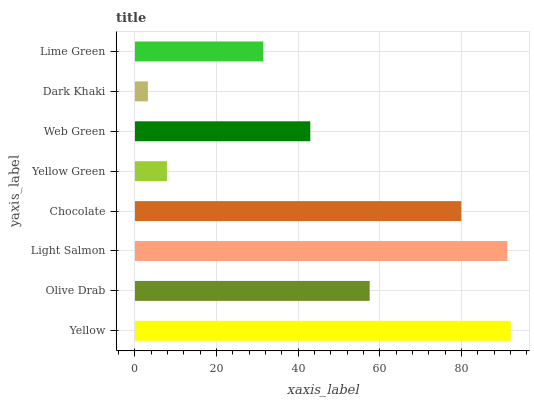Is Dark Khaki the minimum?
Answer yes or no. Yes. Is Yellow the maximum?
Answer yes or no. Yes. Is Olive Drab the minimum?
Answer yes or no. No. Is Olive Drab the maximum?
Answer yes or no. No. Is Yellow greater than Olive Drab?
Answer yes or no. Yes. Is Olive Drab less than Yellow?
Answer yes or no. Yes. Is Olive Drab greater than Yellow?
Answer yes or no. No. Is Yellow less than Olive Drab?
Answer yes or no. No. Is Olive Drab the high median?
Answer yes or no. Yes. Is Web Green the low median?
Answer yes or no. Yes. Is Yellow the high median?
Answer yes or no. No. Is Yellow Green the low median?
Answer yes or no. No. 